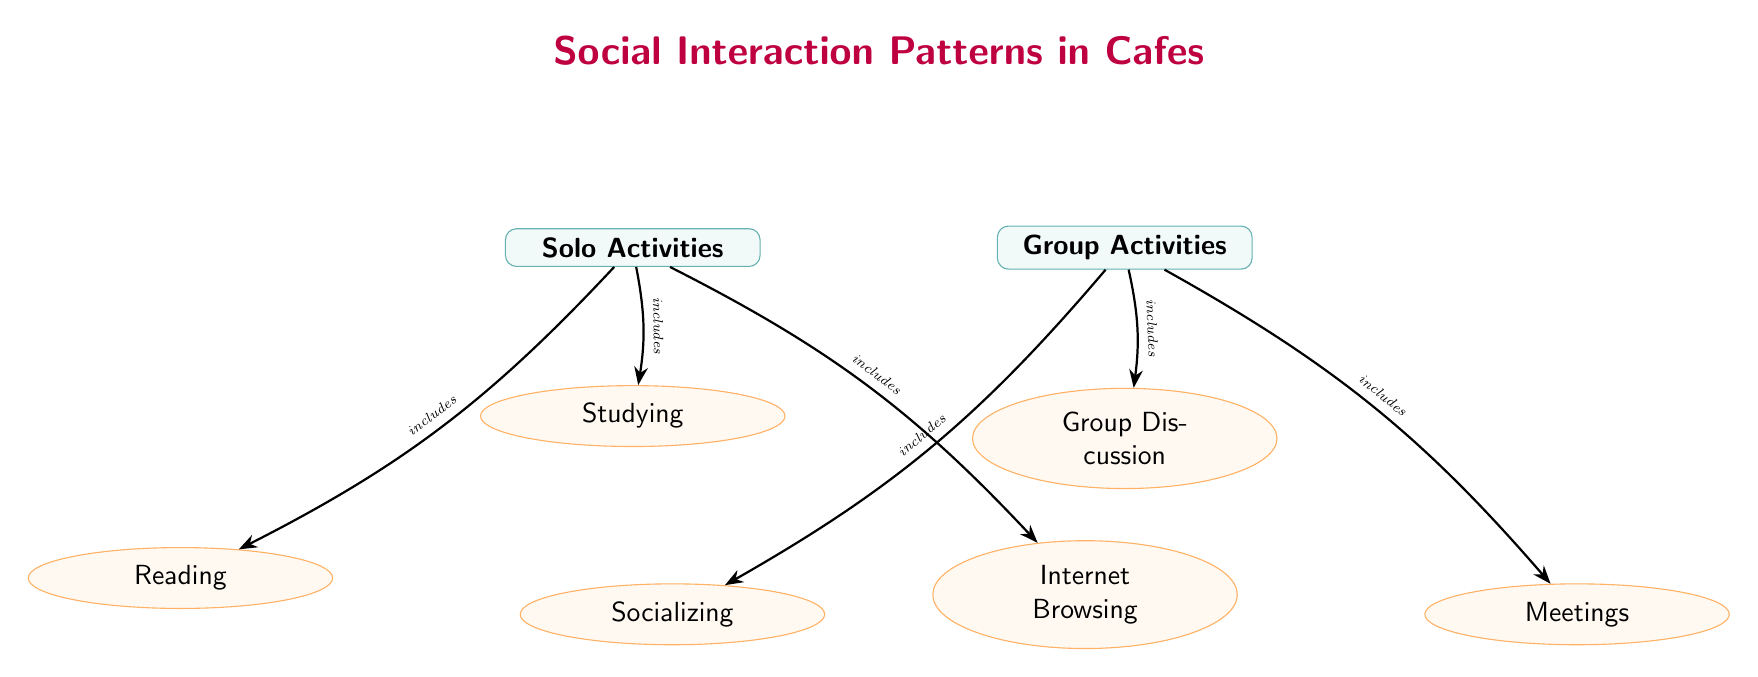What are the two main categories of activities depicted in the diagram? The diagram presents two main categories: Solo Activities and Group Activities. These are clearly labeled as the two primary nodes in the diagram.
Answer: Solo Activities, Group Activities How many sub-nodes are there under Solo Activities? Under Solo Activities, there are three sub-nodes: Studying, Reading, and Internet Browsing. Therefore, the total count is three.
Answer: 3 What type of activity is associated with the sub-node "Group Discussion"? The sub-node "Group Discussion" falls under the category of Group Activities. This is established by tracing a connection from the main Group Activities node.
Answer: Group Activities Which activity is included in the Solo Activities category that involves digital engagement? The activity that involves digital engagement under Solo Activities is Internet Browsing, as indicated in the sub-nodes listed under this category.
Answer: Internet Browsing Which two activities are classified under Group Activities? The activities under Group Activities include Group Discussion and Socializing. These two are part of the three sub-nodes branching from the Group Activities main node.
Answer: Group Discussion, Socializing In terms of layout, how are the sub-nodes arranged under Solo Activities? The sub-nodes under Solo Activities are arranged vertically, with Studying at the top, followed by Reading on the left, and Internet Browsing on the right, creating a visually balanced structure.
Answer: Vertically Which group activity is focused on conversation? The activity focused on conversation under Group Activities is Group Discussion, highlighted as a sub-node connected to the main Group Activities node.
Answer: Group Discussion What visual element connects the main nodes to the sub-nodes? The edges connect the main nodes Solo Activities and Group Activities to their respective sub-nodes, facilitating the understanding of their relationships and inclusion.
Answer: Edges How many total sub-nodes are present in the diagram? There are a total of six sub-nodes present in the diagram: three under Solo Activities and three under Group Activities, leading to a total of six.
Answer: 6 